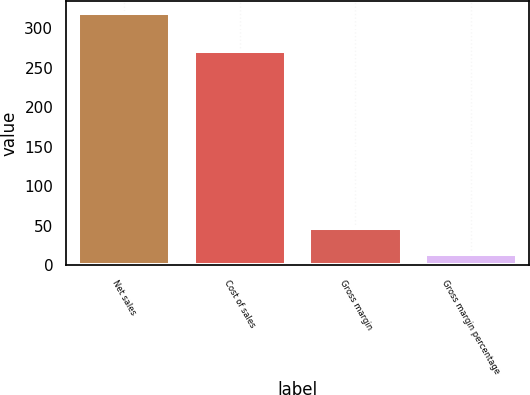Convert chart. <chart><loc_0><loc_0><loc_500><loc_500><bar_chart><fcel>Net sales<fcel>Cost of sales<fcel>Gross margin<fcel>Gross margin percentage<nl><fcel>319<fcel>272<fcel>47<fcel>14.7<nl></chart> 